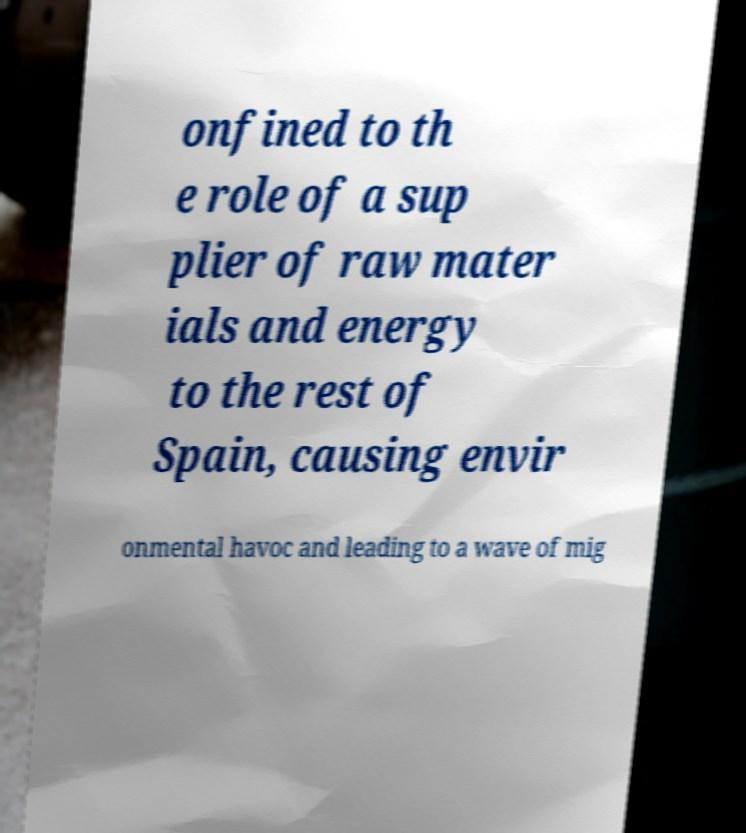There's text embedded in this image that I need extracted. Can you transcribe it verbatim? onfined to th e role of a sup plier of raw mater ials and energy to the rest of Spain, causing envir onmental havoc and leading to a wave of mig 